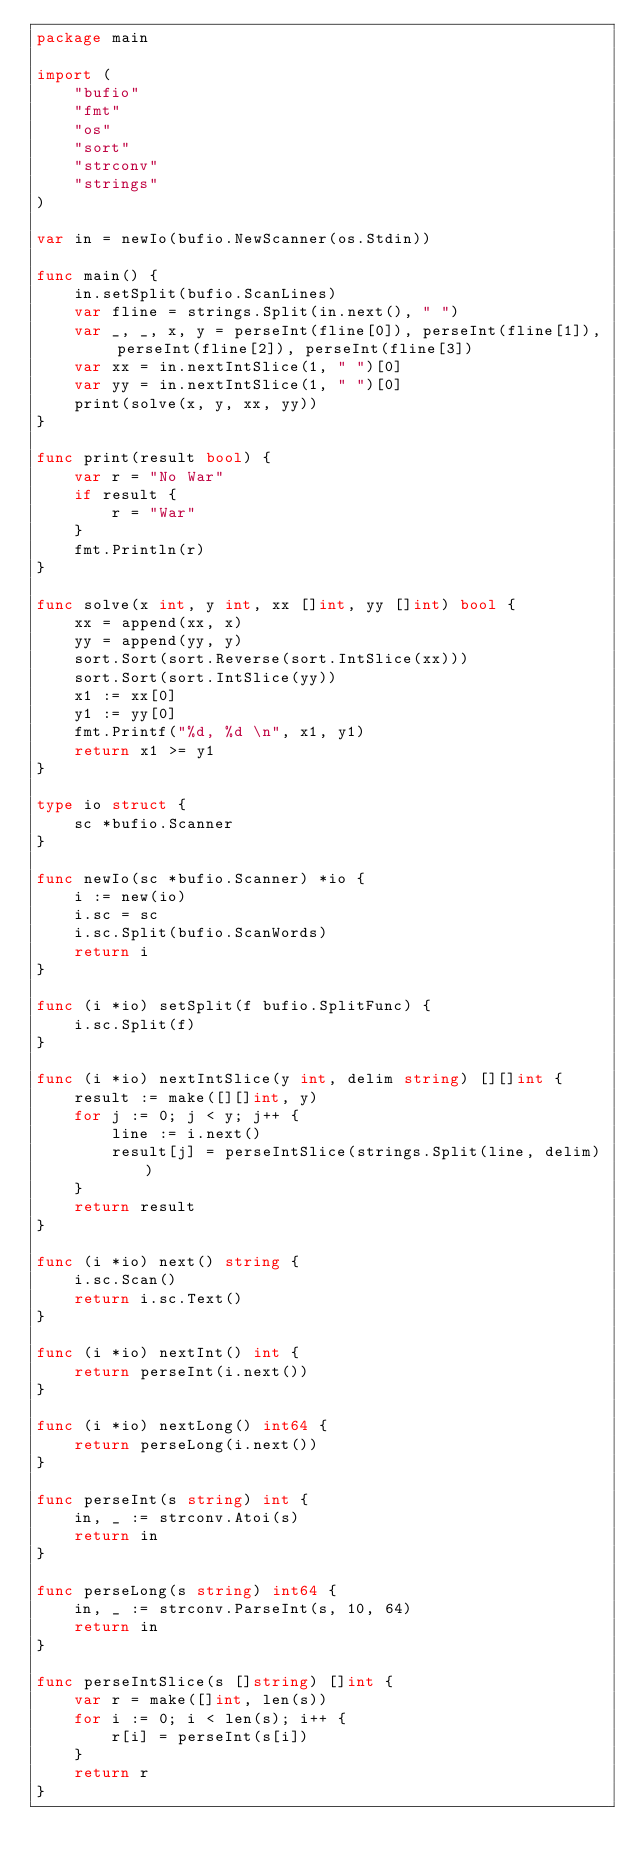<code> <loc_0><loc_0><loc_500><loc_500><_Go_>package main

import (
	"bufio"
	"fmt"
	"os"
	"sort"
	"strconv"
	"strings"
)

var in = newIo(bufio.NewScanner(os.Stdin))

func main() {
	in.setSplit(bufio.ScanLines)
	var fline = strings.Split(in.next(), " ")
	var _, _, x, y = perseInt(fline[0]), perseInt(fline[1]), perseInt(fline[2]), perseInt(fline[3])
	var xx = in.nextIntSlice(1, " ")[0]
	var yy = in.nextIntSlice(1, " ")[0]
	print(solve(x, y, xx, yy))
}

func print(result bool) {
	var r = "No War"
	if result {
		r = "War"
	}
	fmt.Println(r)
}

func solve(x int, y int, xx []int, yy []int) bool {
	xx = append(xx, x)
	yy = append(yy, y)
	sort.Sort(sort.Reverse(sort.IntSlice(xx)))
	sort.Sort(sort.IntSlice(yy))
	x1 := xx[0]
	y1 := yy[0]
	fmt.Printf("%d, %d \n", x1, y1)
	return x1 >= y1
}

type io struct {
	sc *bufio.Scanner
}

func newIo(sc *bufio.Scanner) *io {
	i := new(io)
	i.sc = sc
	i.sc.Split(bufio.ScanWords)
	return i
}

func (i *io) setSplit(f bufio.SplitFunc) {
	i.sc.Split(f)
}

func (i *io) nextIntSlice(y int, delim string) [][]int {
	result := make([][]int, y)
	for j := 0; j < y; j++ {
		line := i.next()
		result[j] = perseIntSlice(strings.Split(line, delim))
	}
	return result
}

func (i *io) next() string {
	i.sc.Scan()
	return i.sc.Text()
}

func (i *io) nextInt() int {
	return perseInt(i.next())
}

func (i *io) nextLong() int64 {
	return perseLong(i.next())
}

func perseInt(s string) int {
	in, _ := strconv.Atoi(s)
	return in
}

func perseLong(s string) int64 {
	in, _ := strconv.ParseInt(s, 10, 64)
	return in
}

func perseIntSlice(s []string) []int {
	var r = make([]int, len(s))
	for i := 0; i < len(s); i++ {
		r[i] = perseInt(s[i])
	}
	return r
}
</code> 